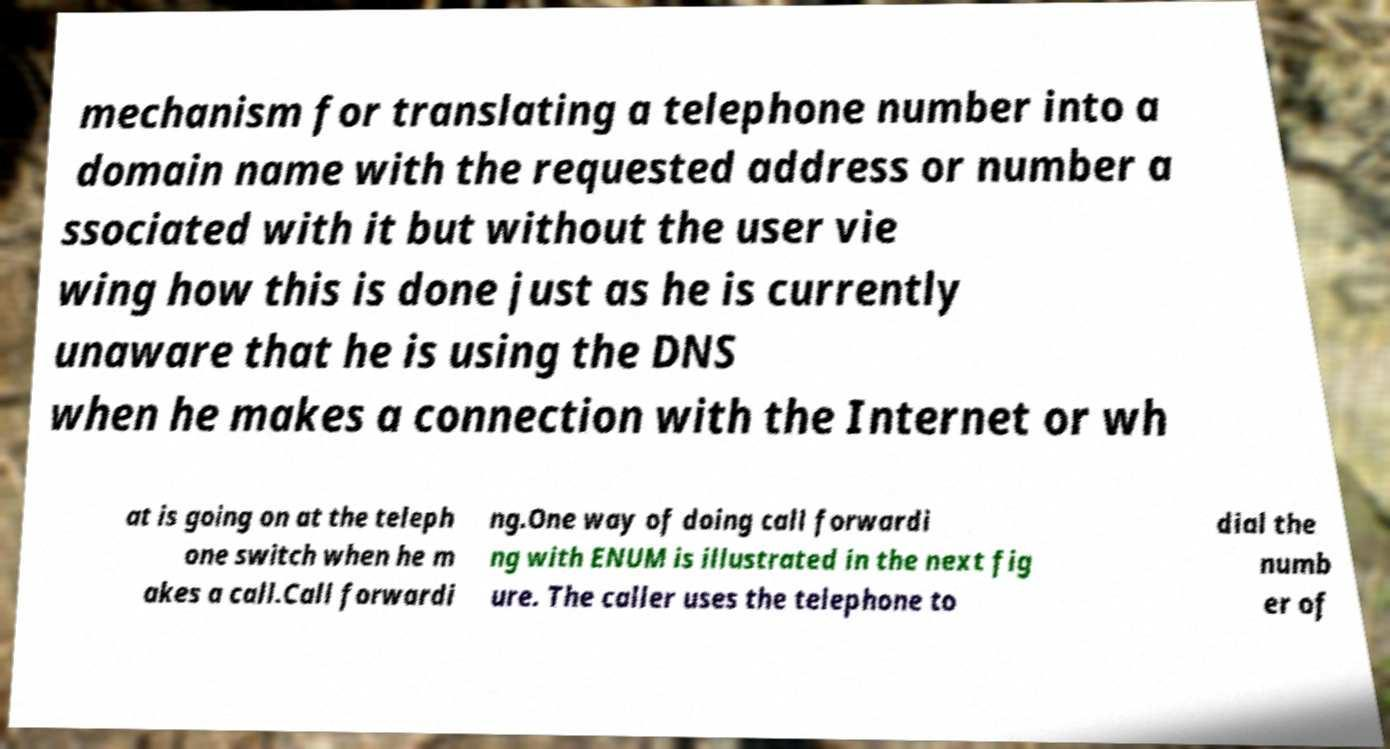Can you read and provide the text displayed in the image?This photo seems to have some interesting text. Can you extract and type it out for me? mechanism for translating a telephone number into a domain name with the requested address or number a ssociated with it but without the user vie wing how this is done just as he is currently unaware that he is using the DNS when he makes a connection with the Internet or wh at is going on at the teleph one switch when he m akes a call.Call forwardi ng.One way of doing call forwardi ng with ENUM is illustrated in the next fig ure. The caller uses the telephone to dial the numb er of 